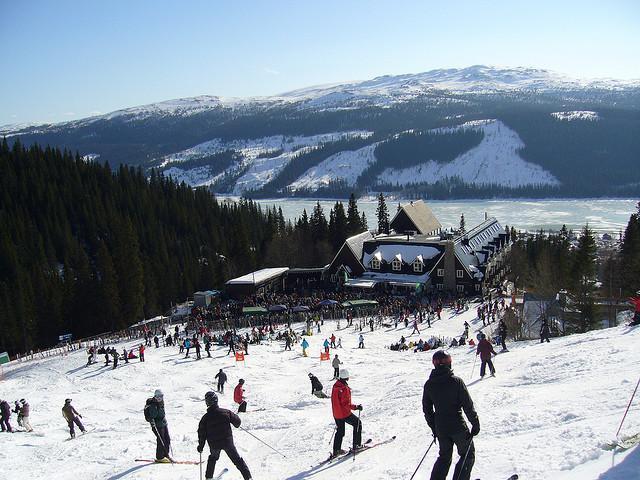How many people are in the picture?
Give a very brief answer. 3. How many zebras are there?
Give a very brief answer. 0. 